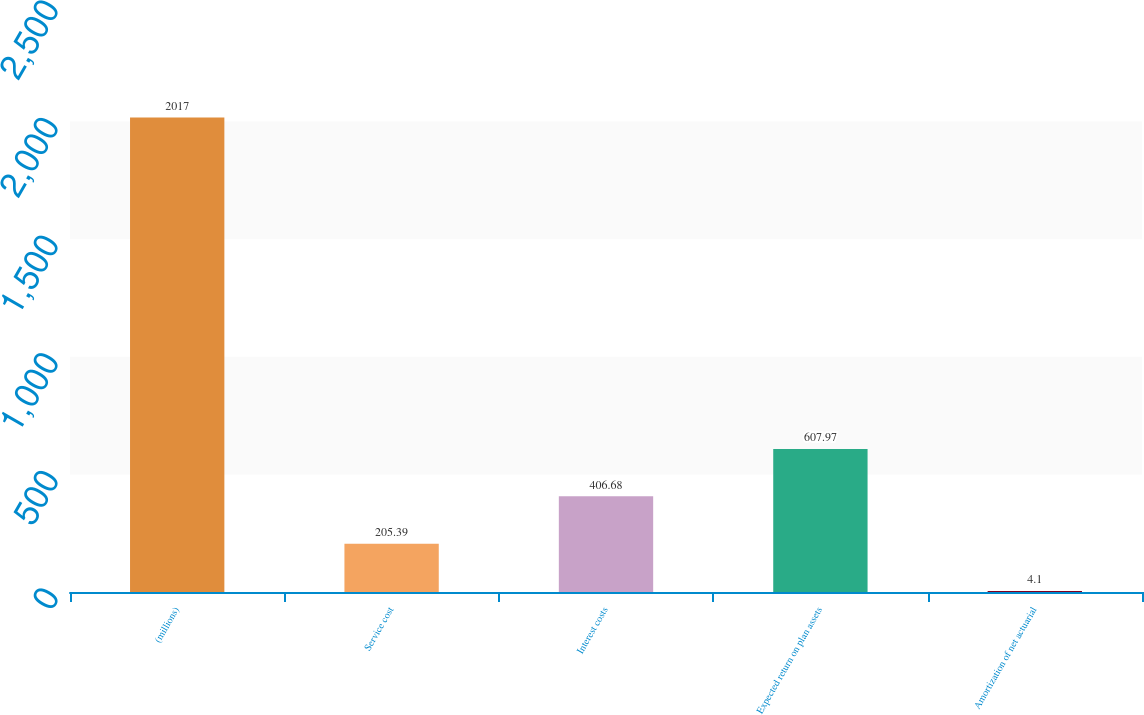Convert chart. <chart><loc_0><loc_0><loc_500><loc_500><bar_chart><fcel>(millions)<fcel>Service cost<fcel>Interest costs<fcel>Expected return on plan assets<fcel>Amortization of net actuarial<nl><fcel>2017<fcel>205.39<fcel>406.68<fcel>607.97<fcel>4.1<nl></chart> 